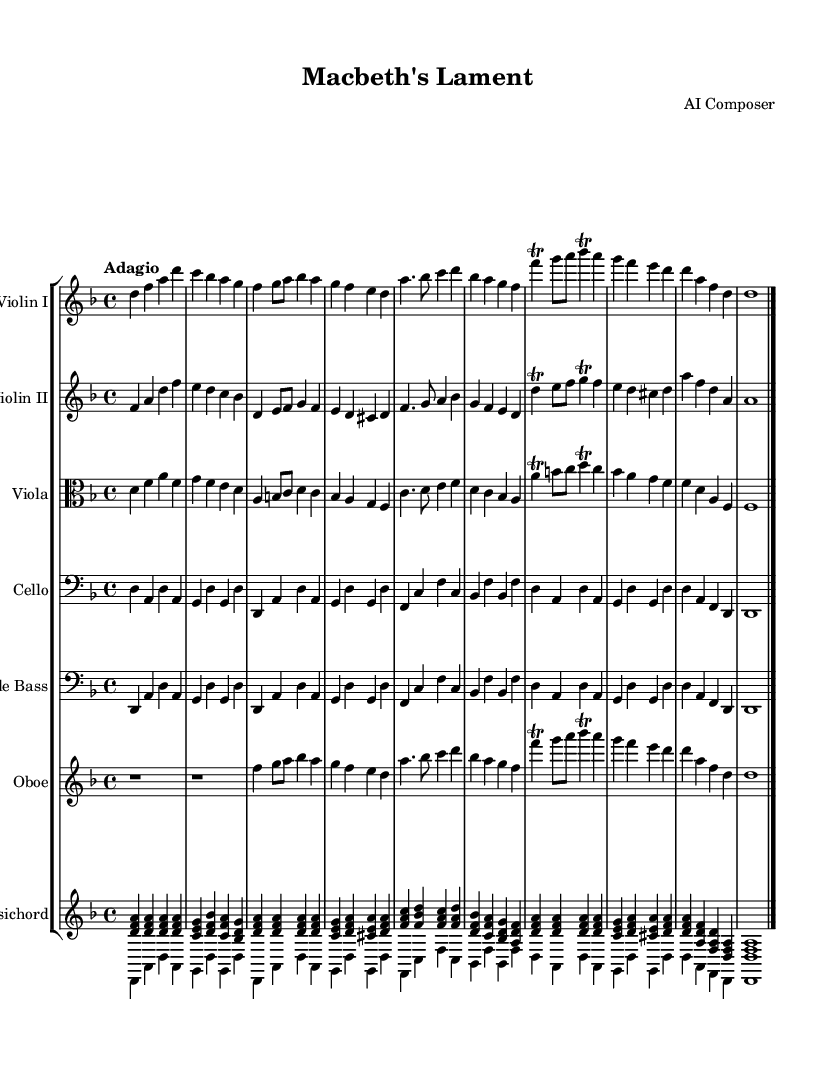What is the key signature of this music? The key signature shown at the beginning of the music indicates D minor, which has one flat. The "bes" indicated by the flat sign confirms this.
Answer: D minor What is the time signature of this music? The time signature is indicated as 4/4 at the beginning, which indicates four beats in a measure. This can be seen in the upper part of the staff.
Answer: 4/4 What is the tempo marking of this piece? The tempo is indicated as "Adagio," which specifies a slow and leisurely pace for the piece, commonly understood in classical music.
Answer: Adagio How many instruments are featured in this orchestral suite? By counting the different staff representations in the score, there are a total of six different instruments: two violins, viola, cello, double bass, and oboe, along with the harpsichord.
Answer: Six What is the name of the composition? The title "Macbeth's Lament" is found in the header section of the sheet music. This title suggests a direct connection to Shakespeare's "Macbeth."
Answer: Macbeth's Lament Which instrument plays a trill in the theme? The trill is indicated in the violin and viola parts in the score, specifically showing the grace note and the main note to be articulated in rapid succession.
Answer: Violin I and Viola What is the character of the harmony used in the harpsichord part? The harpsichord part predominantly uses triadic harmonies, with many triads indicating consonant intervals throughout the piece, contributing to the overall tonality.
Answer: Triadic harmonies 